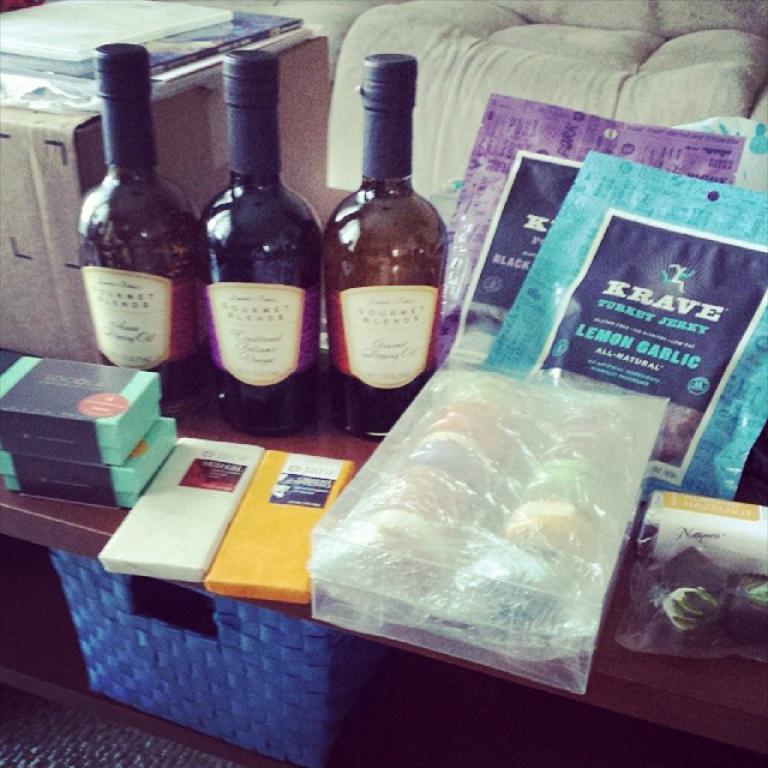What brand of lemon garlic jerky is shown?
Provide a short and direct response. Krave. What flavor of jerky is shown?
Keep it short and to the point. Lemon garlic. 